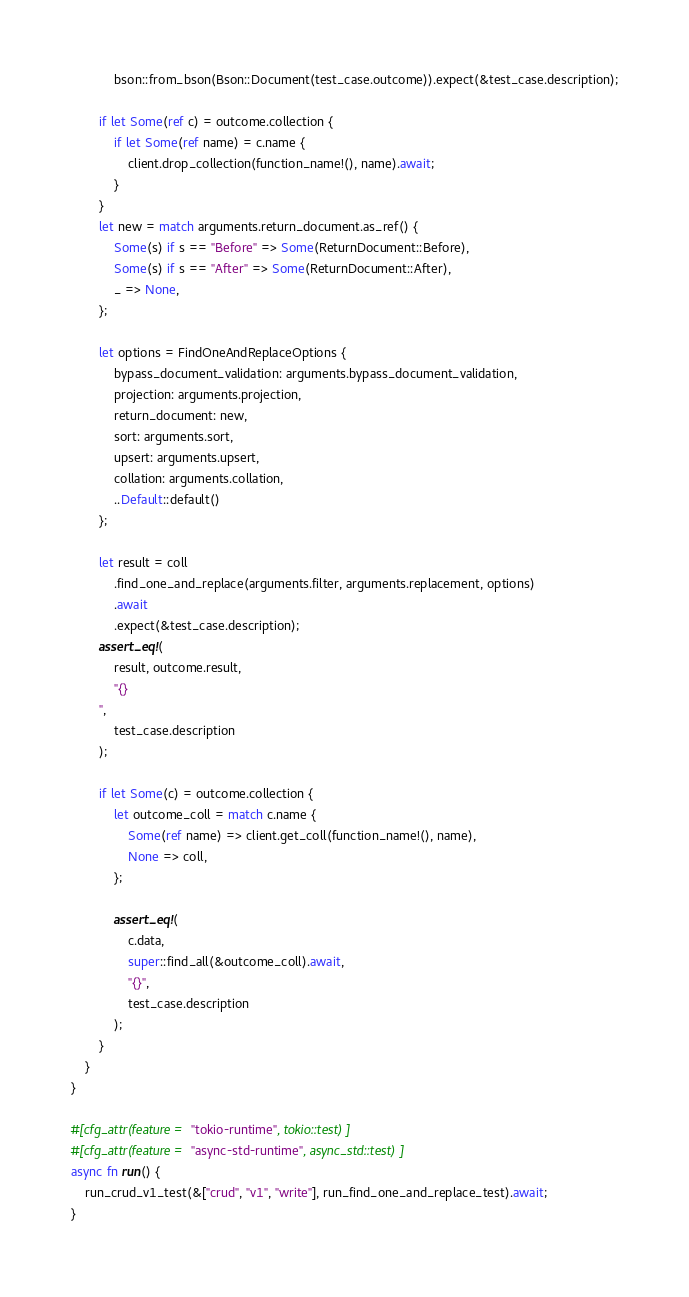Convert code to text. <code><loc_0><loc_0><loc_500><loc_500><_Rust_>            bson::from_bson(Bson::Document(test_case.outcome)).expect(&test_case.description);

        if let Some(ref c) = outcome.collection {
            if let Some(ref name) = c.name {
                client.drop_collection(function_name!(), name).await;
            }
        }
        let new = match arguments.return_document.as_ref() {
            Some(s) if s == "Before" => Some(ReturnDocument::Before),
            Some(s) if s == "After" => Some(ReturnDocument::After),
            _ => None,
        };

        let options = FindOneAndReplaceOptions {
            bypass_document_validation: arguments.bypass_document_validation,
            projection: arguments.projection,
            return_document: new,
            sort: arguments.sort,
            upsert: arguments.upsert,
            collation: arguments.collation,
            ..Default::default()
        };

        let result = coll
            .find_one_and_replace(arguments.filter, arguments.replacement, options)
            .await
            .expect(&test_case.description);
        assert_eq!(
            result, outcome.result,
            "{}
        ",
            test_case.description
        );

        if let Some(c) = outcome.collection {
            let outcome_coll = match c.name {
                Some(ref name) => client.get_coll(function_name!(), name),
                None => coll,
            };

            assert_eq!(
                c.data,
                super::find_all(&outcome_coll).await,
                "{}",
                test_case.description
            );
        }
    }
}

#[cfg_attr(feature = "tokio-runtime", tokio::test)]
#[cfg_attr(feature = "async-std-runtime", async_std::test)]
async fn run() {
    run_crud_v1_test(&["crud", "v1", "write"], run_find_one_and_replace_test).await;
}
</code> 